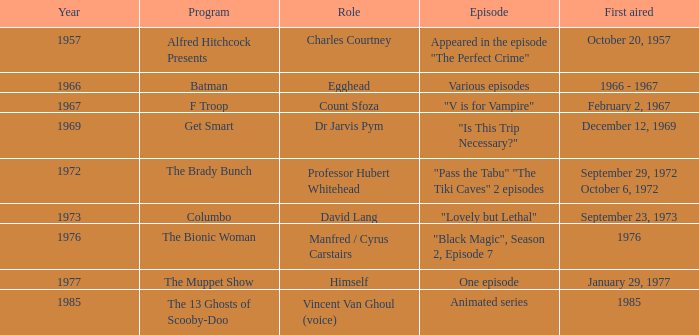What's the roles of the Bionic Woman? Manfred / Cyrus Carstairs. 